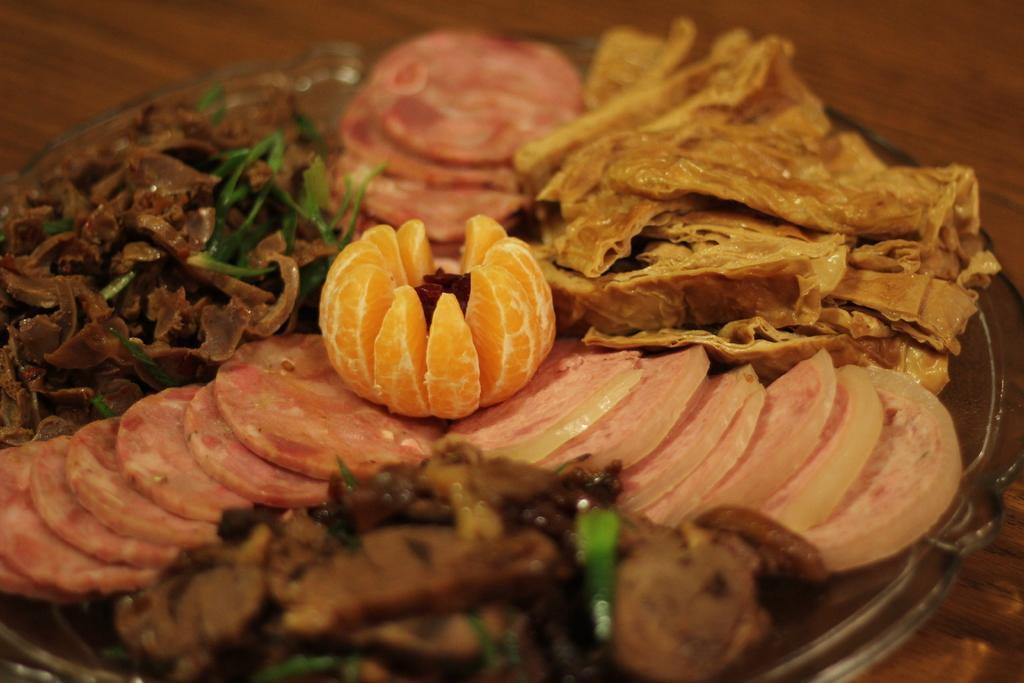Can you describe this image briefly? In the center of the image we can see a bowl containing food placed on the table. 